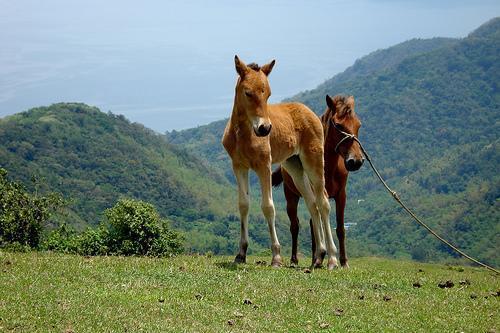How many donkeys are shown?
Give a very brief answer. 2. 